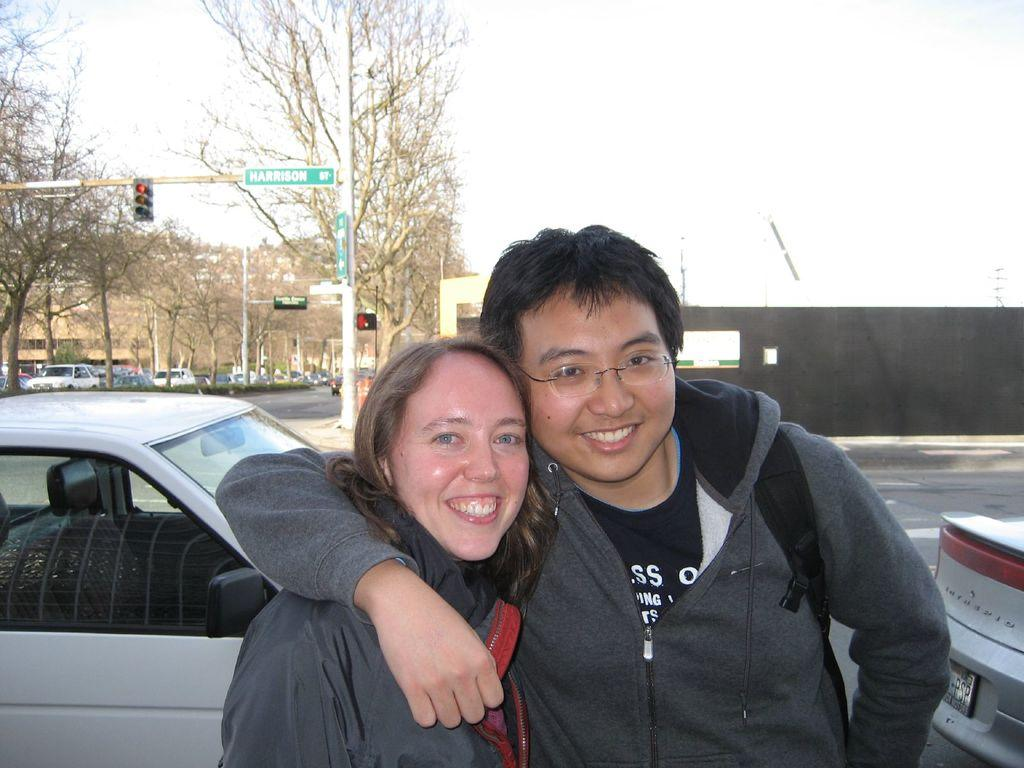How many people are standing on the road in the image? There are two people standing on the road in the image. What else can be seen on the road besides the people? There are cars on the road. What is located in the background of the image? There is a traffic signal and trees in the background, as well as the sky. What type of bells can be heard ringing in the image? There are no bells present in the image, and therefore no sound can be heard. Can you tell me if the people in the image have a pet with them? There is no pet visible in the image. 